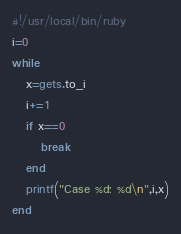<code> <loc_0><loc_0><loc_500><loc_500><_Ruby_>#!/usr/local/bin/ruby
i=0
while
   x=gets.to_i
   i+=1
   if x==0
      break
   end
   printf("Case %d: %d\n",i,x)
end</code> 